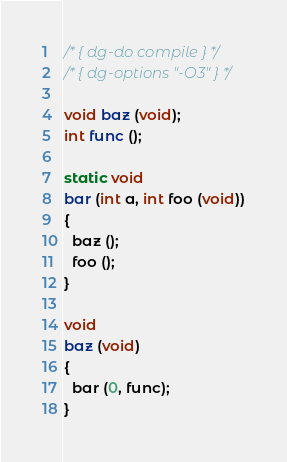Convert code to text. <code><loc_0><loc_0><loc_500><loc_500><_C_>/* { dg-do compile } */
/* { dg-options "-O3" } */

void baz (void);
int func ();

static void
bar (int a, int foo (void))
{
  baz ();
  foo ();
}

void
baz (void)
{
  bar (0, func);
}
</code> 